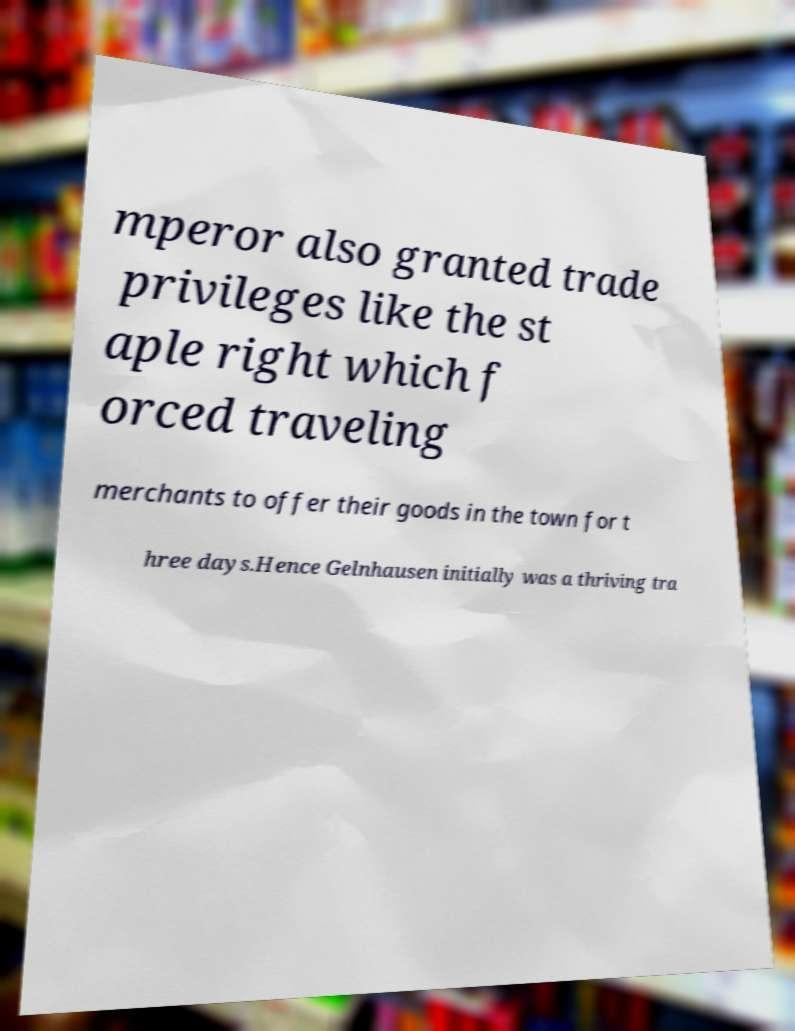For documentation purposes, I need the text within this image transcribed. Could you provide that? mperor also granted trade privileges like the st aple right which f orced traveling merchants to offer their goods in the town for t hree days.Hence Gelnhausen initially was a thriving tra 